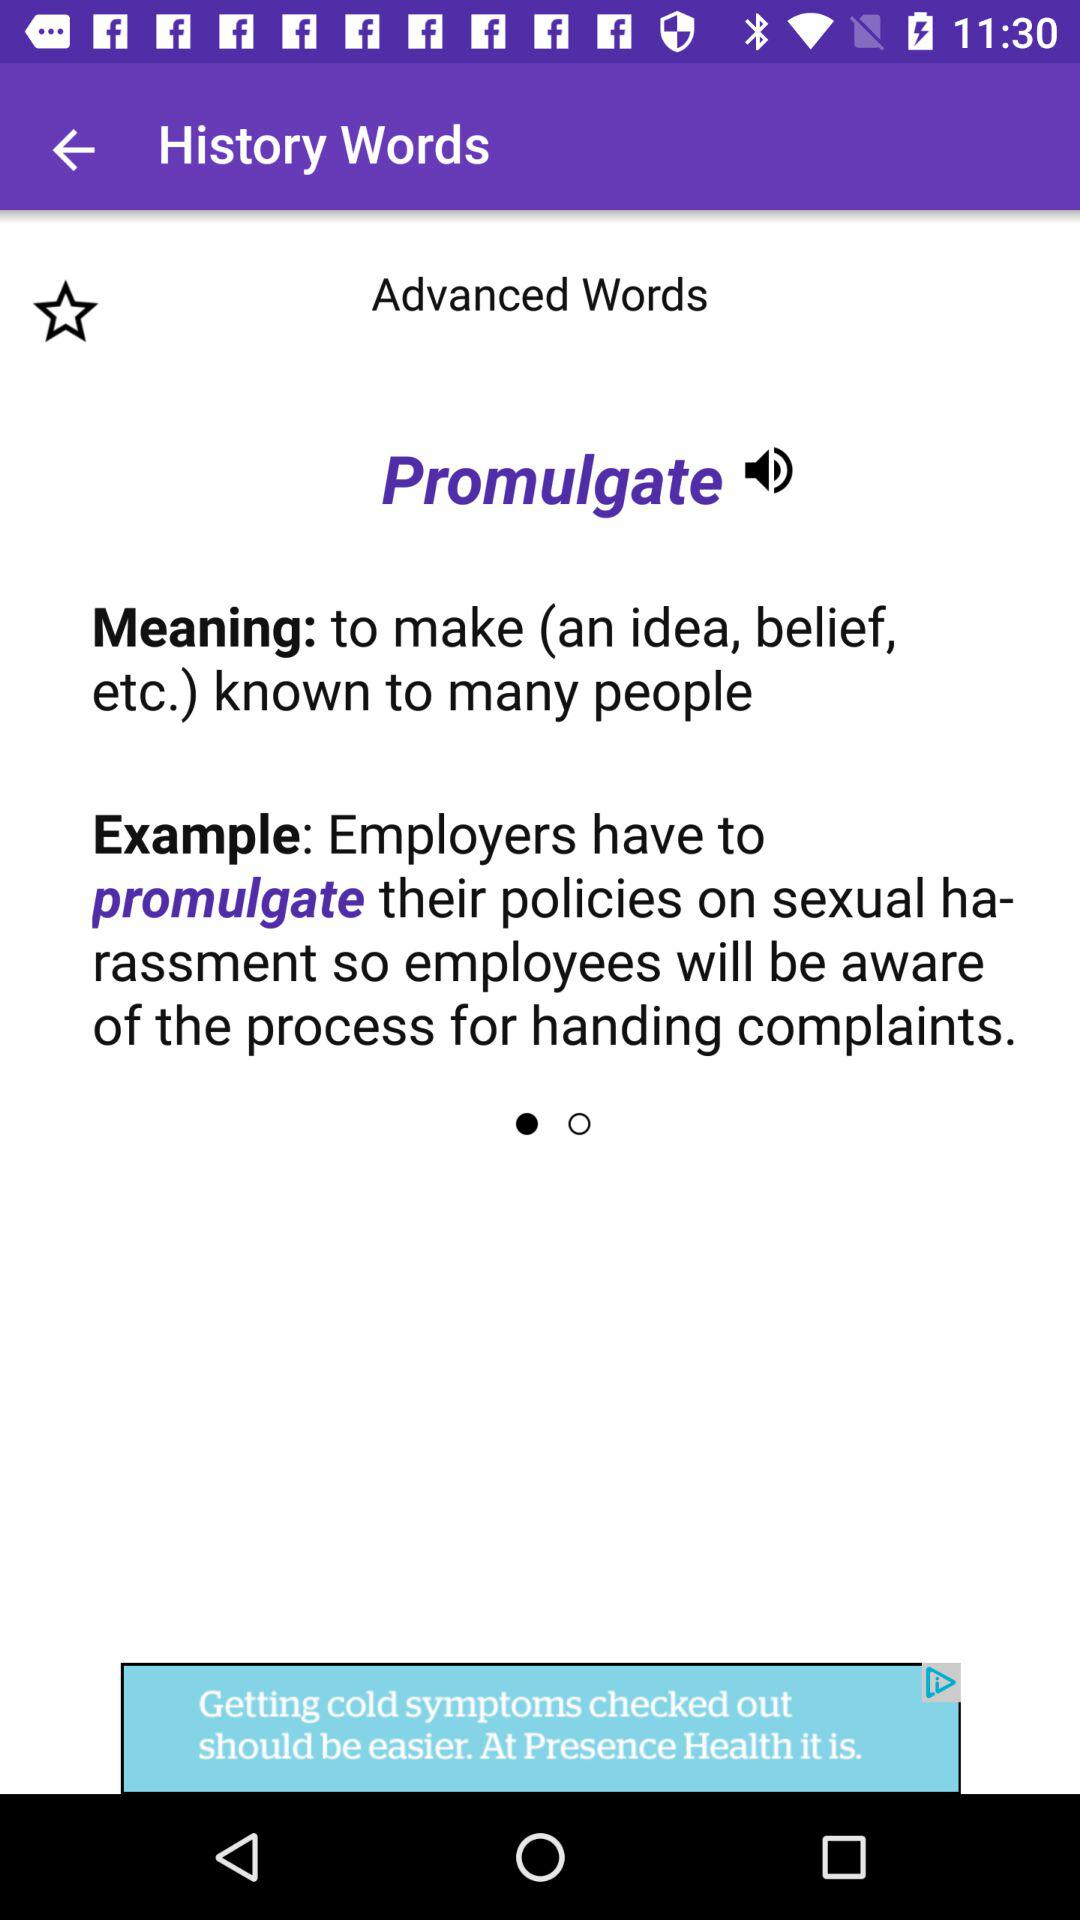What is the meaning of promulgate? The meaning of promulgate is "to make (an idea, belief, etc.) known to many people". 